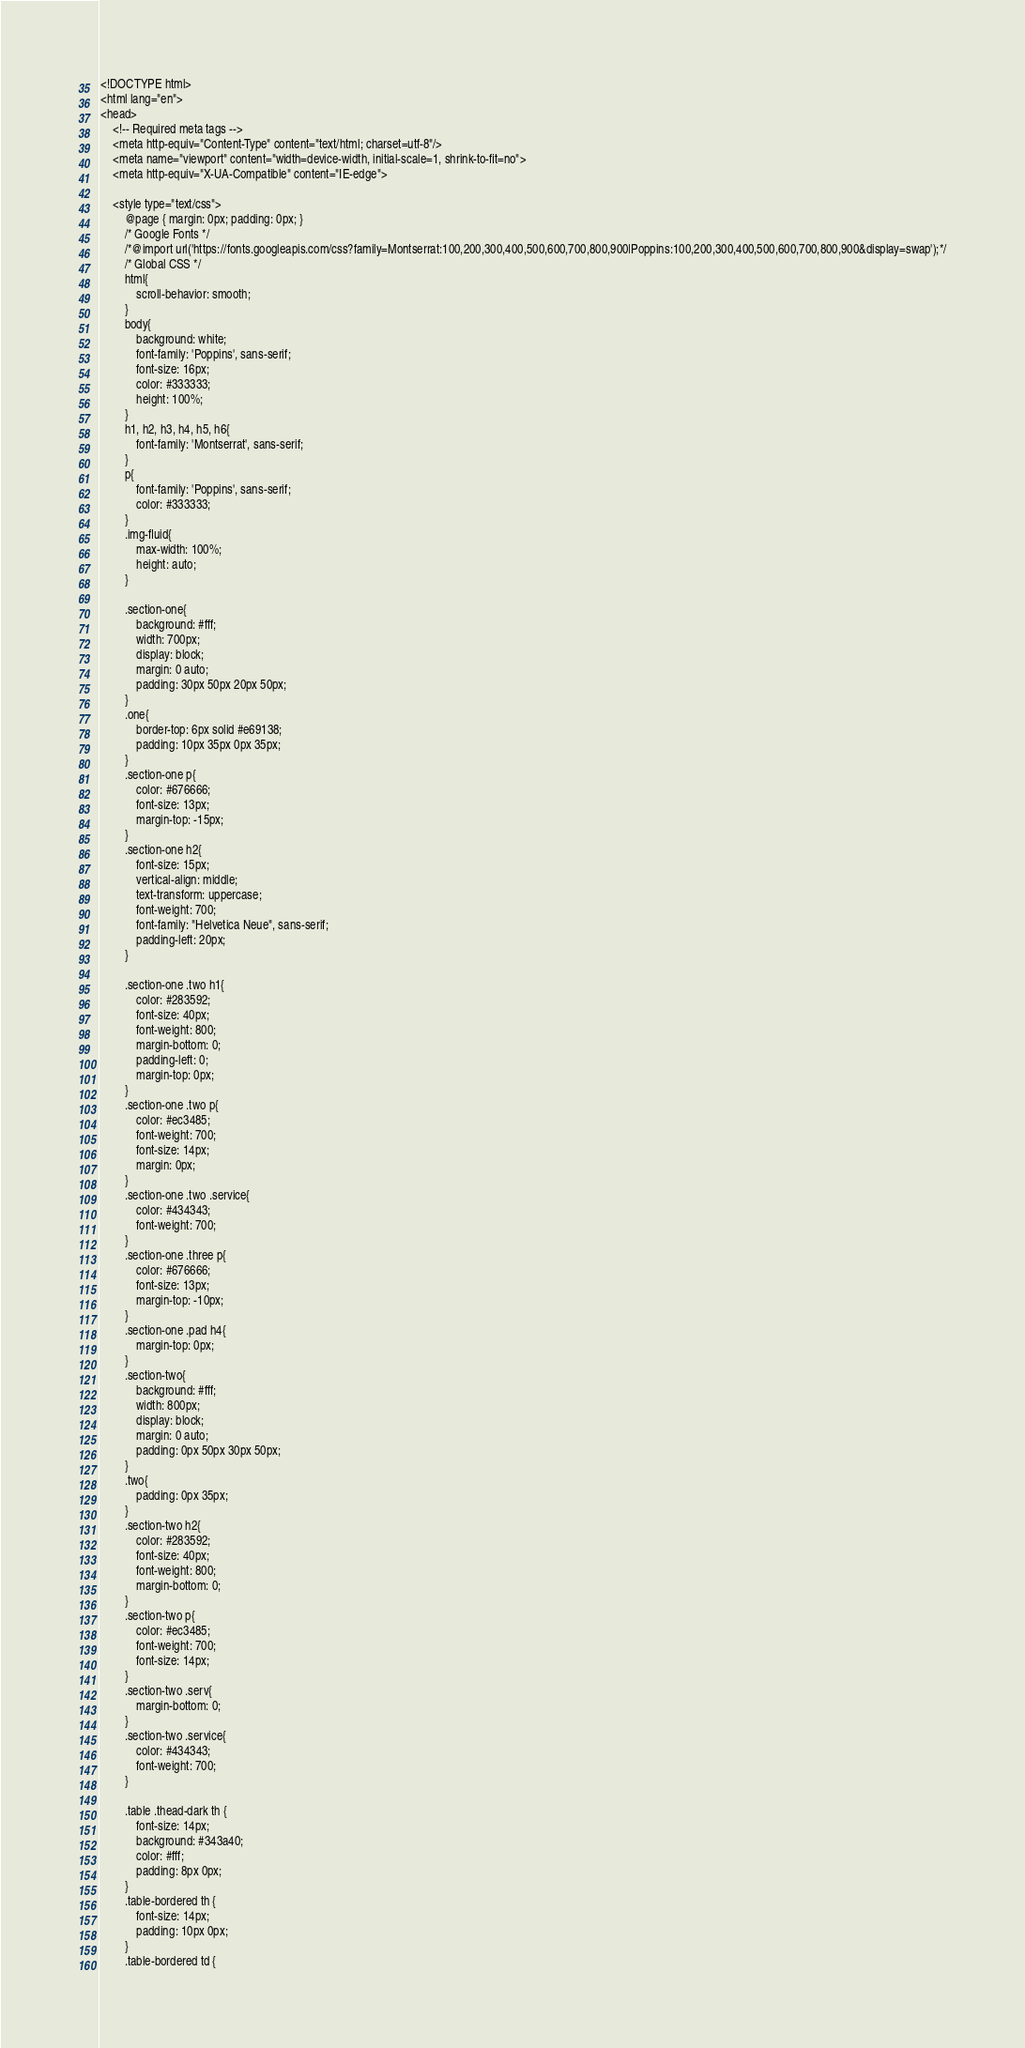<code> <loc_0><loc_0><loc_500><loc_500><_PHP_><!DOCTYPE html>
<html lang="en">
<head>
    <!-- Required meta tags -->
    <meta http-equiv="Content-Type" content="text/html; charset=utf-8"/>
    <meta name="viewport" content="width=device-width, initial-scale=1, shrink-to-fit=no">
    <meta http-equiv="X-UA-Compatible" content="IE-edge">

    <style type="text/css">
        @page { margin: 0px; padding: 0px; }
        /* Google Fonts */
        /*@import url('https://fonts.googleapis.com/css?family=Montserrat:100,200,300,400,500,600,700,800,900|Poppins:100,200,300,400,500,600,700,800,900&display=swap');*/
        /* Global CSS */
        html{
            scroll-behavior: smooth;
        }
        body{
            background: white;
            font-family: 'Poppins', sans-serif;
            font-size: 16px;
            color: #333333;
            height: 100%;
        }
        h1, h2, h3, h4, h5, h6{
            font-family: 'Montserrat', sans-serif;
        }
        p{
            font-family: 'Poppins', sans-serif;
            color: #333333;
        }
        .img-fluid{
            max-width: 100%;
            height: auto;
        }

        .section-one{
            background: #fff;
            width: 700px;
            display: block;
            margin: 0 auto;
            padding: 30px 50px 20px 50px;
        }
        .one{
            border-top: 6px solid #e69138;
            padding: 10px 35px 0px 35px;
        }
        .section-one p{
            color: #676666;
            font-size: 13px;
            margin-top: -15px;
        }
        .section-one h2{
            font-size: 15px;
            vertical-align: middle;
            text-transform: uppercase;
            font-weight: 700;
            font-family: "Helvetica Neue", sans-serif;
            padding-left: 20px;
        }

        .section-one .two h1{
            color: #283592;
            font-size: 40px;
            font-weight: 800;
            margin-bottom: 0;
            padding-left: 0;
            margin-top: 0px;
        }
        .section-one .two p{
            color: #ec3485;
            font-weight: 700;
            font-size: 14px;
            margin: 0px;
        }
        .section-one .two .service{
            color: #434343;
            font-weight: 700;
        }
        .section-one .three p{
            color: #676666;
            font-size: 13px;
            margin-top: -10px;
        }
        .section-one .pad h4{
            margin-top: 0px;
        }
        .section-two{
            background: #fff;
            width: 800px;
            display: block;
            margin: 0 auto;
            padding: 0px 50px 30px 50px;
        }
        .two{
            padding: 0px 35px;
        }
        .section-two h2{
            color: #283592;
            font-size: 40px;
            font-weight: 800;
            margin-bottom: 0;
        }
        .section-two p{
            color: #ec3485;
            font-weight: 700;
            font-size: 14px;
        }
        .section-two .serv{
            margin-bottom: 0;
        }
        .section-two .service{
            color: #434343;
            font-weight: 700;
        }

        .table .thead-dark th {
            font-size: 14px;
            background: #343a40;
            color: #fff;
            padding: 8px 0px;
        }
        .table-bordered th {
            font-size: 14px;
            padding: 10px 0px;
        }
        .table-bordered td {</code> 